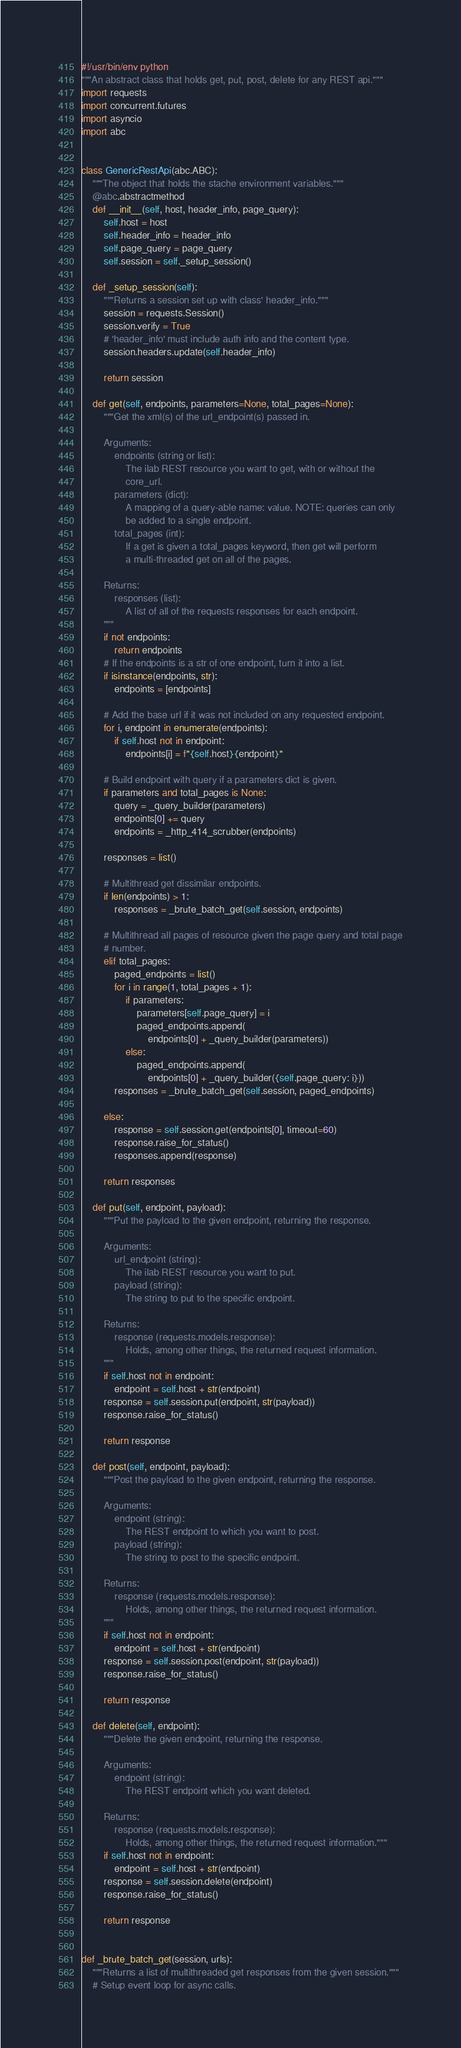<code> <loc_0><loc_0><loc_500><loc_500><_Python_>#!/usr/bin/env python
"""An abstract class that holds get, put, post, delete for any REST api."""
import requests
import concurrent.futures
import asyncio
import abc


class GenericRestApi(abc.ABC):
    """The object that holds the stache environment variables."""
    @abc.abstractmethod
    def __init__(self, host, header_info, page_query):
        self.host = host
        self.header_info = header_info
        self.page_query = page_query
        self.session = self._setup_session()

    def _setup_session(self):
        """Returns a session set up with class' header_info."""
        session = requests.Session()
        session.verify = True
        # 'header_info' must include auth info and the content type.
        session.headers.update(self.header_info)

        return session

    def get(self, endpoints, parameters=None, total_pages=None):
        """Get the xml(s) of the url_endpoint(s) passed in.

        Arguments:
            endpoints (string or list):
                The ilab REST resource you want to get, with or without the
                core_url.
            parameters (dict):
                A mapping of a query-able name: value. NOTE: queries can only
                be added to a single endpoint.
            total_pages (int):
                If a get is given a total_pages keyword, then get will perform
                a multi-threaded get on all of the pages.

        Returns:
            responses (list):
                A list of all of the requests responses for each endpoint.
        """
        if not endpoints:
            return endpoints
        # If the endpoints is a str of one endpoint, turn it into a list.
        if isinstance(endpoints, str):
            endpoints = [endpoints]

        # Add the base url if it was not included on any requested endpoint.
        for i, endpoint in enumerate(endpoints):
            if self.host not in endpoint:
                endpoints[i] = f"{self.host}{endpoint}"

        # Build endpoint with query if a parameters dict is given.
        if parameters and total_pages is None:
            query = _query_builder(parameters)
            endpoints[0] += query
            endpoints = _http_414_scrubber(endpoints)

        responses = list()

        # Multithread get dissimilar endpoints.
        if len(endpoints) > 1:
            responses = _brute_batch_get(self.session, endpoints)

        # Multithread all pages of resource given the page query and total page
        # number.
        elif total_pages:
            paged_endpoints = list()
            for i in range(1, total_pages + 1):
                if parameters:
                    parameters[self.page_query] = i
                    paged_endpoints.append(
                        endpoints[0] + _query_builder(parameters))
                else:
                    paged_endpoints.append(
                        endpoints[0] + _query_builder({self.page_query: i}))
            responses = _brute_batch_get(self.session, paged_endpoints)

        else:
            response = self.session.get(endpoints[0], timeout=60)
            response.raise_for_status()
            responses.append(response)

        return responses

    def put(self, endpoint, payload):
        """Put the payload to the given endpoint, returning the response.

        Arguments:
            url_endpoint (string):
                The ilab REST resource you want to put.
            payload (string):
                The string to put to the specific endpoint.

        Returns:
            response (requests.models.response):
                Holds, among other things, the returned request information.
        """
        if self.host not in endpoint:
            endpoint = self.host + str(endpoint)
        response = self.session.put(endpoint, str(payload))
        response.raise_for_status()

        return response

    def post(self, endpoint, payload):
        """Post the payload to the given endpoint, returning the response.

        Arguments:
            endpoint (string):
                The REST endpoint to which you want to post.
            payload (string):
                The string to post to the specific endpoint.

        Returns:
            response (requests.models.response):
                Holds, among other things, the returned request information.
        """
        if self.host not in endpoint:
            endpoint = self.host + str(endpoint)
        response = self.session.post(endpoint, str(payload))
        response.raise_for_status()

        return response

    def delete(self, endpoint):
        """Delete the given endpoint, returning the response.

        Arguments:
            endpoint (string):
                The REST endpoint which you want deleted.

        Returns:
            response (requests.models.response):
                Holds, among other things, the returned request information."""
        if self.host not in endpoint:
            endpoint = self.host + str(endpoint)
        response = self.session.delete(endpoint)
        response.raise_for_status()

        return response


def _brute_batch_get(session, urls):
    """Returns a list of multithreaded get responses from the given session."""
    # Setup event loop for async calls.</code> 